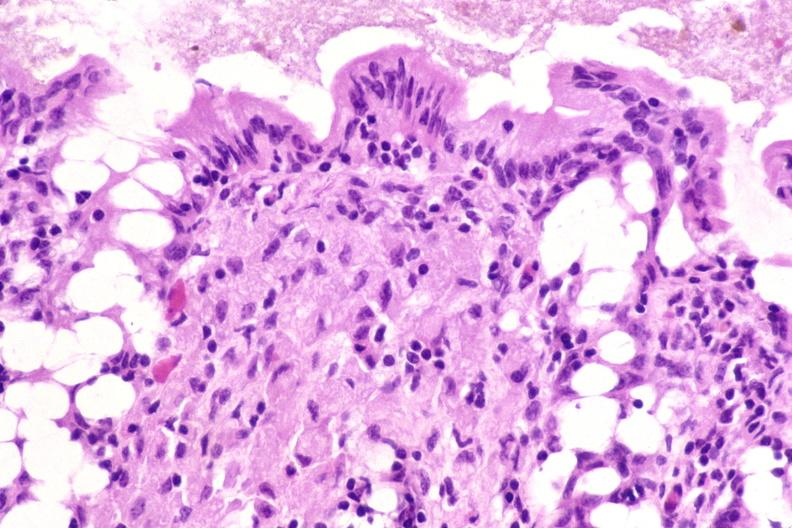what does this image show?
Answer the question using a single word or phrase. Colon biopsy 